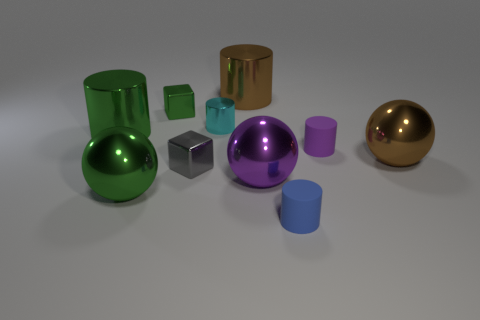Subtract all big purple balls. How many balls are left? 2 Subtract 2 cubes. How many cubes are left? 0 Subtract all blue blocks. Subtract all cyan cylinders. How many blocks are left? 2 Subtract all brown cylinders. How many red spheres are left? 0 Subtract all small things. Subtract all small blue things. How many objects are left? 4 Add 9 tiny gray shiny blocks. How many tiny gray shiny blocks are left? 10 Add 3 gray metallic objects. How many gray metallic objects exist? 4 Subtract all green cubes. How many cubes are left? 1 Subtract 0 blue spheres. How many objects are left? 10 Subtract all blocks. How many objects are left? 8 